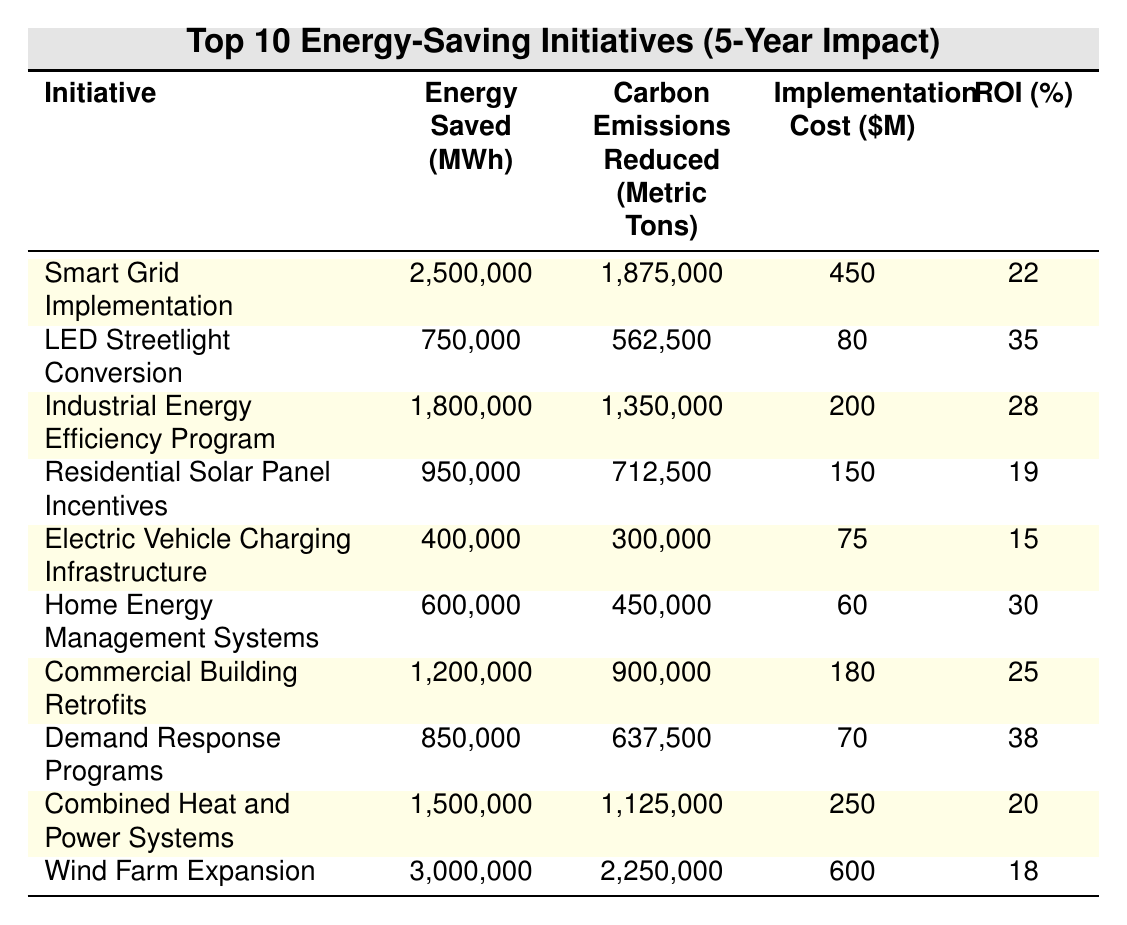What is the total energy saved by all initiatives combined? Sum the energy saved by each initiative: 2,500,000 + 750,000 + 1,800,000 + 950,000 + 400,000 + 600,000 + 1,200,000 + 850,000 + 1,500,000 + 3,000,000 = 13,600,000 MWh
Answer: 13,600,000 MWh Which initiative has the highest carbon emissions reduction? The initiative with the highest carbon emissions reduced is Wind Farm Expansion at 2,250,000 metric tons
Answer: Wind Farm Expansion What is the total implementation cost of all initiatives? Sum the implementation costs: 450 + 80 + 200 + 150 + 75 + 60 + 180 + 70 + 250 + 600 = 2,015 million dollars
Answer: 2,015 million dollars Is the ROI for the Demand Response Programs higher than the ROI for the Electric Vehicle Charging Infrastructure? Demand Response Programs ROI is 38%, and Electric Vehicle Charging Infrastructure ROI is 15%. Yes, 38% > 15%.
Answer: Yes What is the average carbon emissions reduction across all initiatives? Calculate the total carbon emissions reduced: 1,875,000 + 562,500 + 1,350,000 + 712,500 + 300,000 + 450,000 + 900,000 + 637,500 + 1,125,000 + 2,250,000 = 9,687,500 metric tons. Then divide by 10 (number of initiatives): 9,687,500 / 10 = 968,750 metric tons.
Answer: 968,750 metric tons Which initiative has the second highest ROI? The ROIs are: Smart Grid Implementation 22%, LED Streetlight Conversion 35%, Industrial Energy Efficiency Program 28%, etc. Ranking them gives: 1. LED Streetlight Conversion, 2. Industrial Energy Efficiency Program
Answer: Industrial Energy Efficiency Program How much energy savings result in the reduction of carbon emissions for the Wind Farm Expansion? For Wind Farm Expansion, 3,000,000 MWh saved results in a reduction of 2,250,000 metric tons of carbon emissions. The ratio is 2,250,000 / 3,000,000.
Answer: 0.75 metric tons/MWh What is the difference in energy saved between the initiative with the highest and the lowest energy savings? Highest energy saving is Wind Farm Expansion (3,000,000 MWh) and lowest is Electric Vehicle Charging Infrastructure (400,000 MWh). Difference: 3,000,000 - 400,000 = 2,600,000 MWh.
Answer: 2,600,000 MWh Does the LED Streetlight Conversion have a higher implementation cost than the Home Energy Management Systems? LED Streetlight Conversion costs 80 million dollars and Home Energy Management Systems costs 60 million dollars. Yes, 80 > 60.
Answer: Yes What is the total carbon emissions reduction from the top three initiatives? The top three initiatives are Wind Farm Expansion (2,250,000), Smart Grid Implementation (1,875,000), and Industrial Energy Efficiency Program (1,350,000). Total: 2,250,000 + 1,875,000 + 1,350,000 = 5,475,000 metric tons.
Answer: 5,475,000 metric tons 